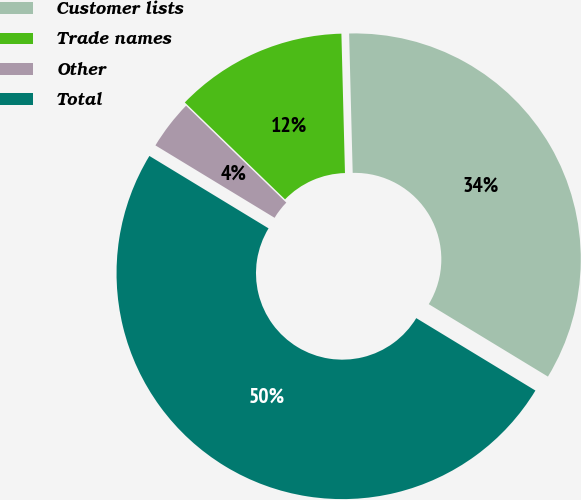Convert chart. <chart><loc_0><loc_0><loc_500><loc_500><pie_chart><fcel>Customer lists<fcel>Trade names<fcel>Other<fcel>Total<nl><fcel>34.1%<fcel>12.36%<fcel>3.54%<fcel>50.0%<nl></chart> 